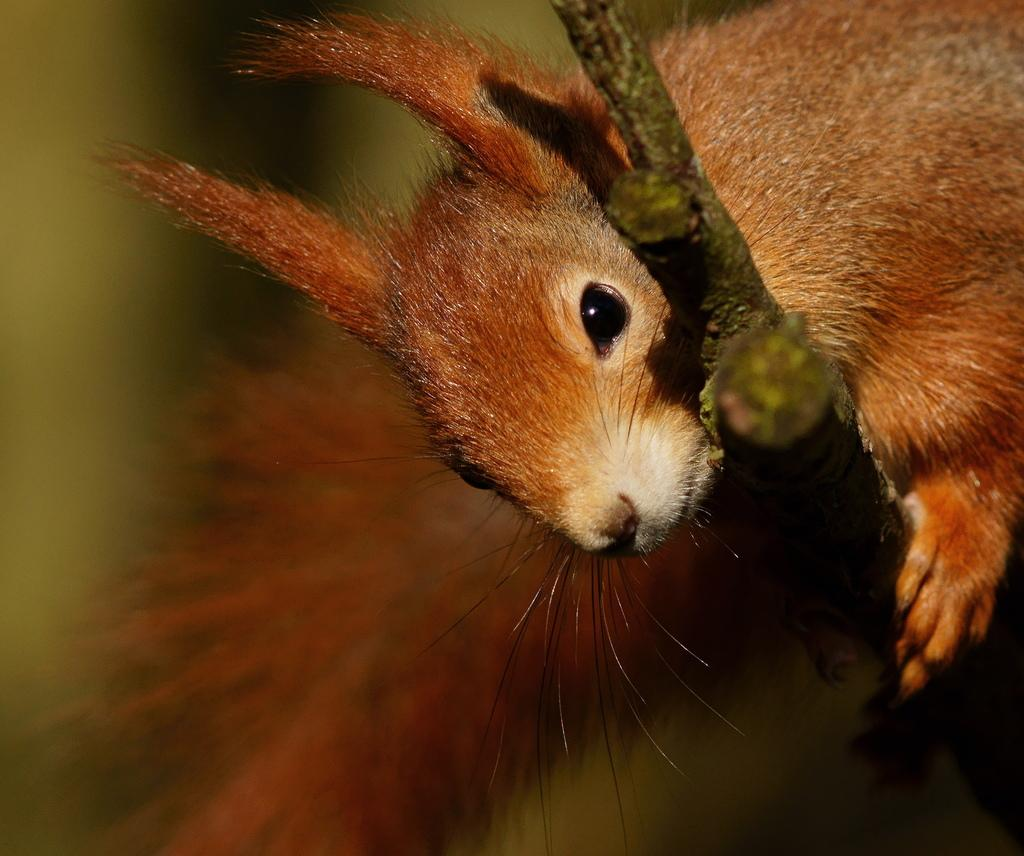What animal can be seen in the image? There is a squirrel in the image. Where is the squirrel located? The squirrel is on a wooden stick. Can you describe the background of the image? The background of the image is blurred. What type of prison can be seen in the background of the image? There is no prison present in the image; the background is blurred. 